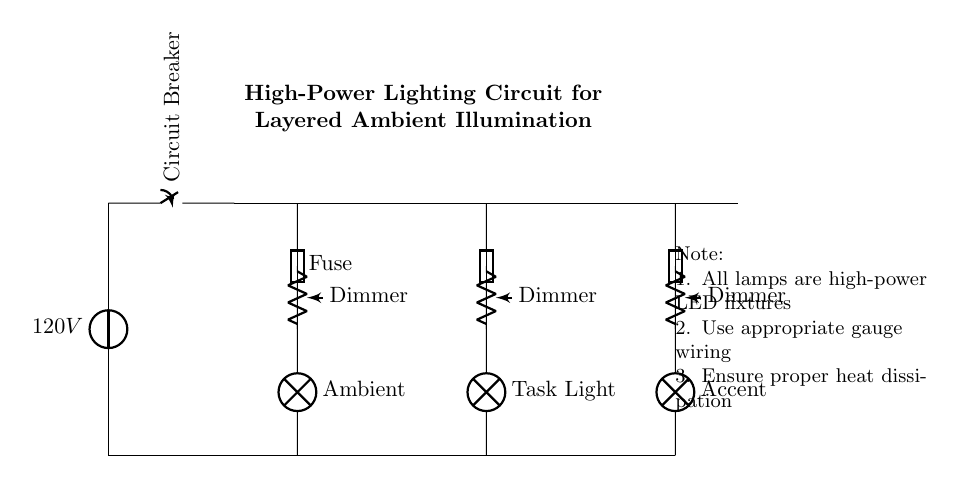What is the voltage of this circuit? The voltage of the circuit is 120V, which is indicated by the voltage source at the beginning of the circuit diagram.
Answer: 120V What types of lighting are included in this circuit? The circuit includes three types of lighting: ambient light, task light, and accent light, which are labeled next to their respective lamps in the diagram.
Answer: Ambient, task, and accent How many fuses are in the circuit? There are three fuses in the circuit, each corresponding to the three lighting circuits (ambient, task, and accent). Each fuse is labeled in the diagram.
Answer: Three What is the purpose of the dimmers in the circuit? The dimmers allow for adjustable brightness for each lighting type, enhancing versatility in the lighting scheme. This is shown as a potentiometer connected to each individual lamp circuit.
Answer: Adjustable brightness What could happen if the wiring gauge is not appropriate for this circuit? If the wiring gauge is insufficient, it can lead to overheating, potential fire hazards, or circuit failure due to the high power requirements of the lighting fixtures. It is essential to use the appropriate gauge to ensure safety and functionality in high-power applications.
Answer: Overheating and fire hazards What is the function of the circuit breaker in this circuit? The circuit breaker serves as a safety device that disconnects the circuit in case of an overload or fault, preventing damage to the system and ensuring safety. It is positioned at the beginning of the circuit after the power source.
Answer: Safety device to prevent overload Why is heat dissipation mentioned in the notes? Heat dissipation is crucial in high-power circuits because excessive heat can damage components or create safety hazards. The note emphasizes ensuring proper cooling mechanisms for the high-power LED fixtures in use.
Answer: To prevent damage and ensure safety 